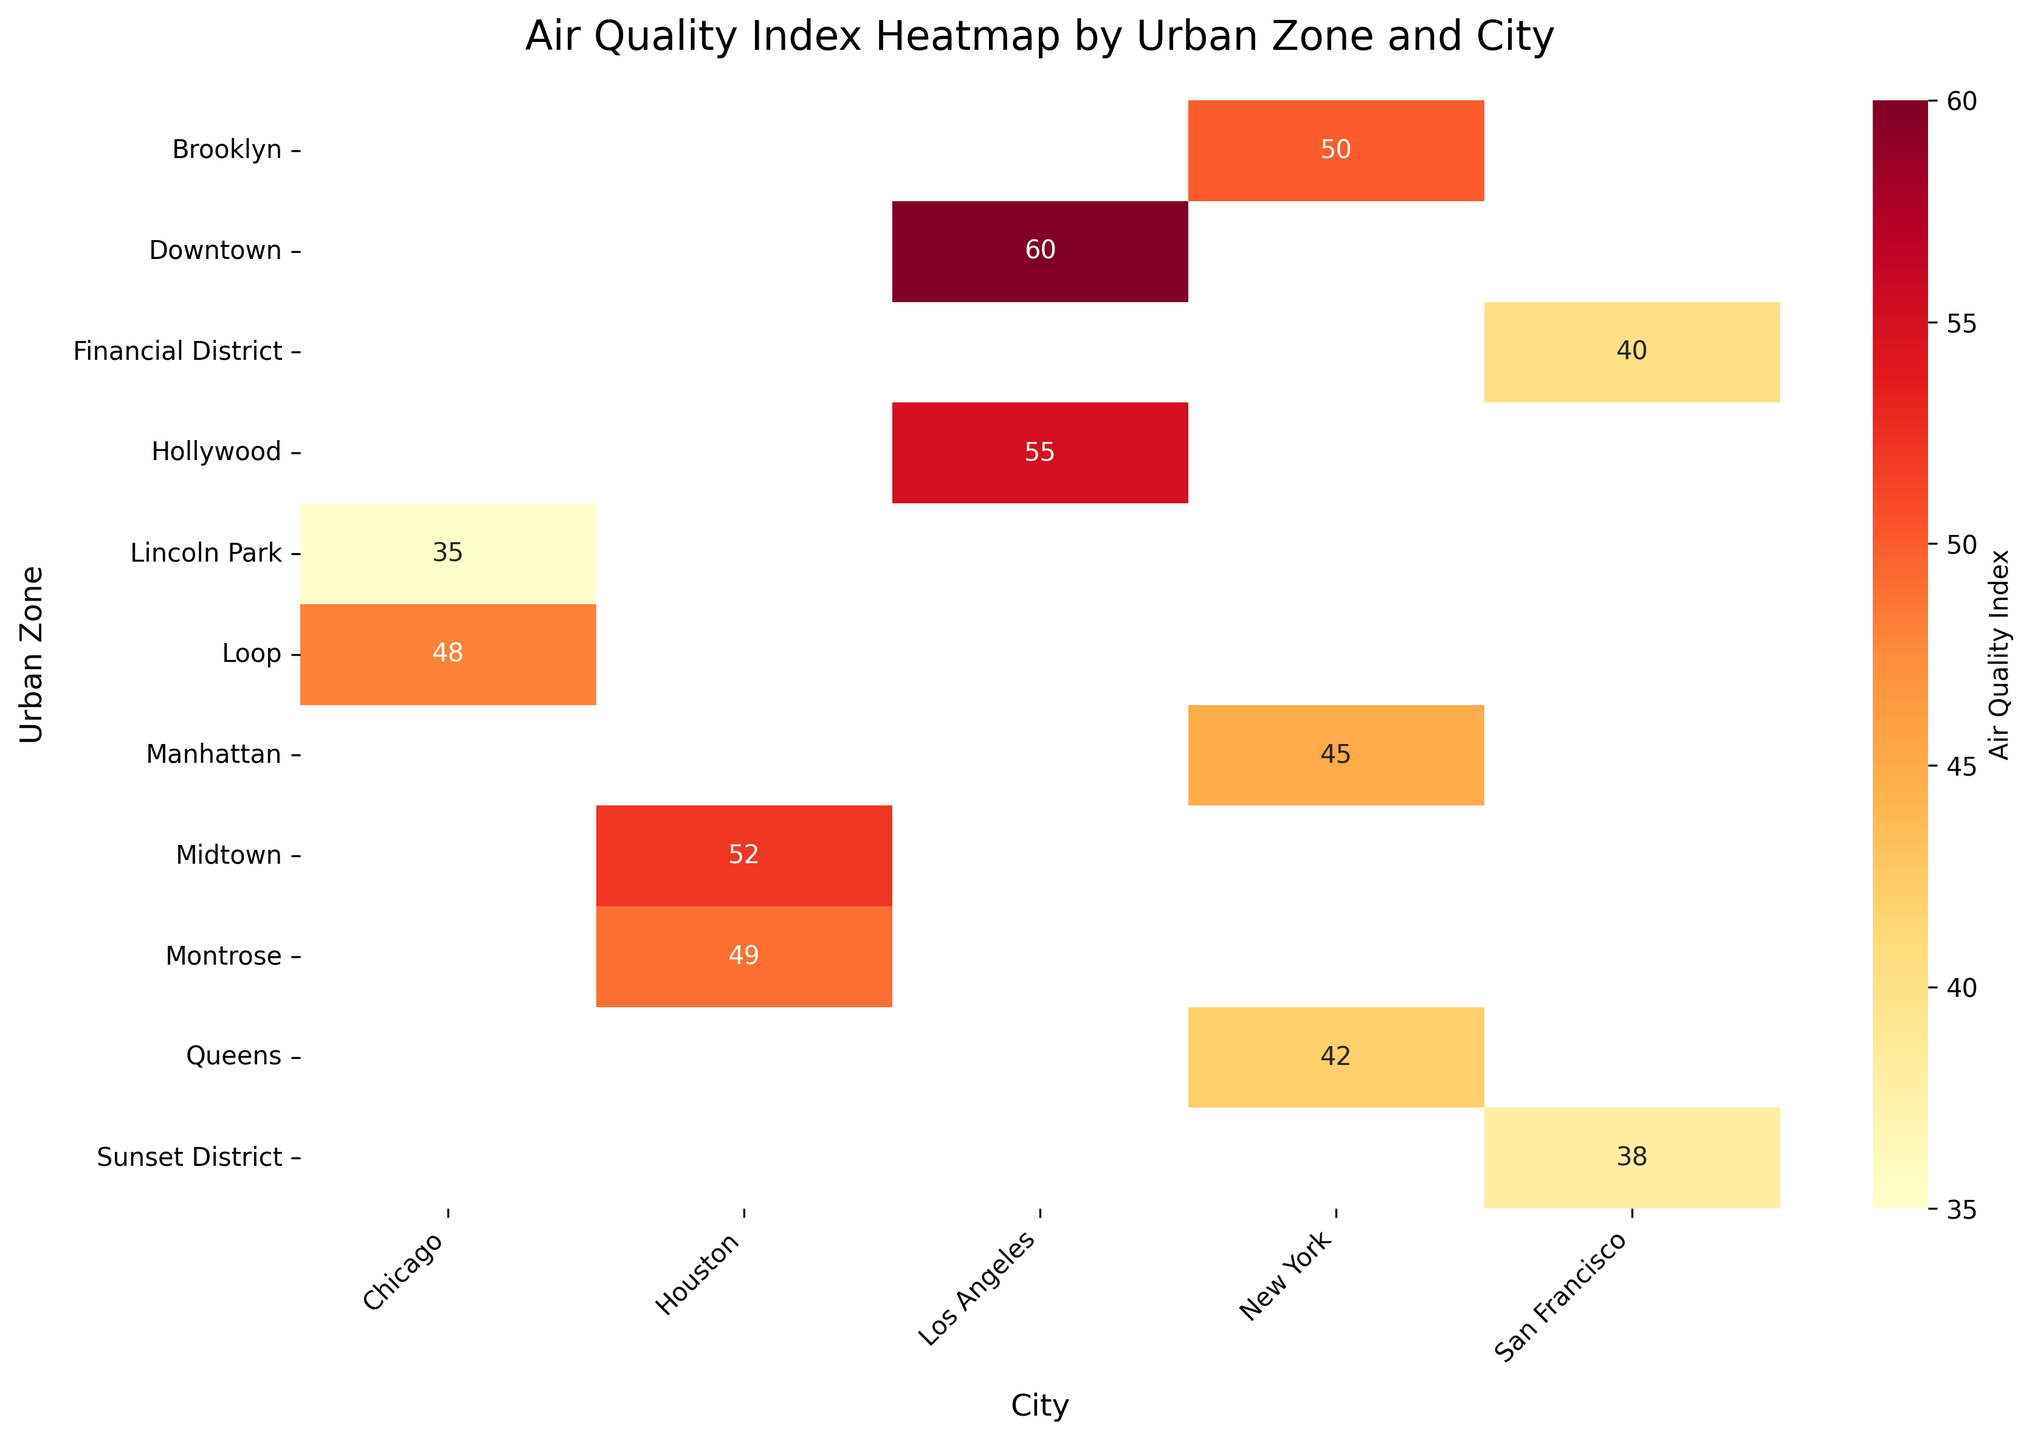What's the title of the heatmap figure? The title is located at the top of the heatmap. Look at the area above the plot grid to find the title text.
Answer: Air Quality Index Heatmap by Urban Zone and City Which urban zone in New York has the highest Air Quality Index? Find the Air Quality Index values for all urban zones listed under New York and identify the highest value
Answer: Brooklyn Compare the Air Quality Index values for Lincoln Park and Hollywood. Which zone has a better air quality? Locate the values for both Lincoln Park (Chicago) and Hollywood (Los Angeles). A lower Air Quality Index indicates better air quality.
Answer: Lincoln Park Which city has the urban zone with the lowest Air Quality Index? Look at all the values in the heatmap and determine the city for which any of the urban zones have the lowest AIQ; see Sunset District in San Francisco with an AIQ of 38
Answer: San Francisco What is the median Air Quality Index across all urban zones in Chicago? First, find all Air Quality Index values for urban zones within Chicago (48 and 35). Order these values (35, 48) and find the middle value (two data points total, so take the average of these two values: (35 + 48)/2
Answer: 41.5 Between Manhattan and Midtown, which urban zone has a worse air quality? Find the Air Quality Index values for both zones, with Manhattan having 45 and Midtown 52. A higher value means worse air quality.
Answer: Midtown How many urban zones have an Air Quality Index greater than 50? Count the number of boxes in the heatmap with values above 50. These include zones in New York (Brooklyn), Los Angeles (Downtown, Hollywood), and Houston (Midtown).
Answer: 4 What is the difference in Air Quality Index between Sunset District and Manhattan? Identify the Air Quality Index values for both urban zones, which are 38 and 45 respectively. Calculate the difference: 45 - 38.
Answer: 7 Which city has the highest average Air Quality Index across its urban zones? Calculate the average Air Quality Index per city and compare them. New York: (45 + 50 + 42)/3 = 45.67; Los Angeles: (60 + 55)/2 = 57.5; Chicago: (48 + 35)/2 = 41.5; Houston: (52 + 49)/2 = 50.5; San Francisco: (40 + 38)/2 = 39. Find the highest value.
Answer: Los Angeles 